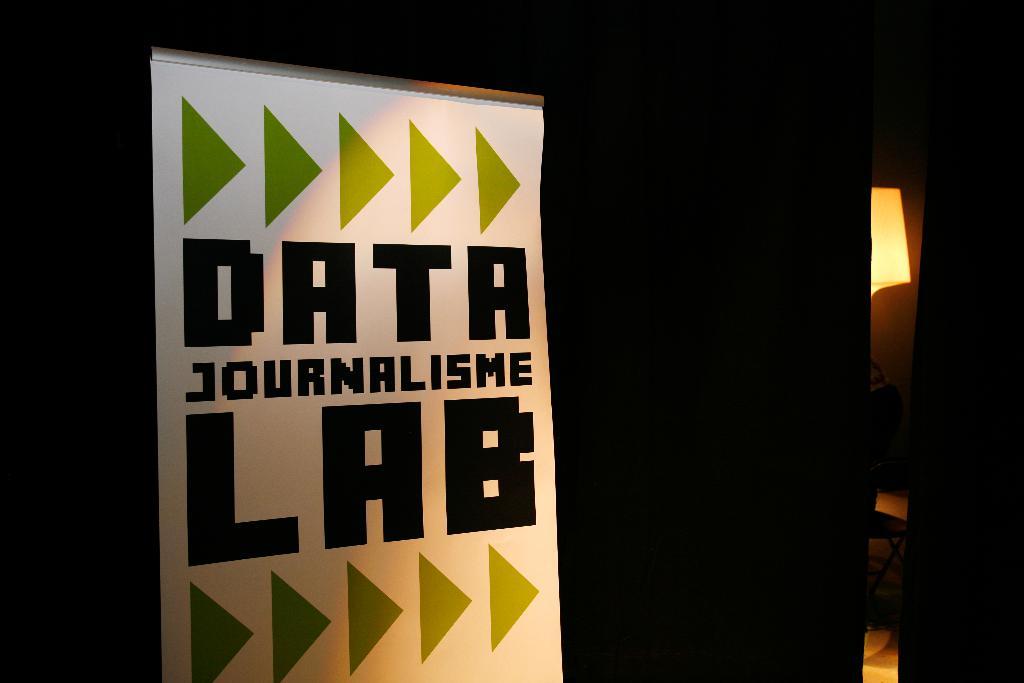What kind of lab is this?
Make the answer very short. Data journalisme lab. 